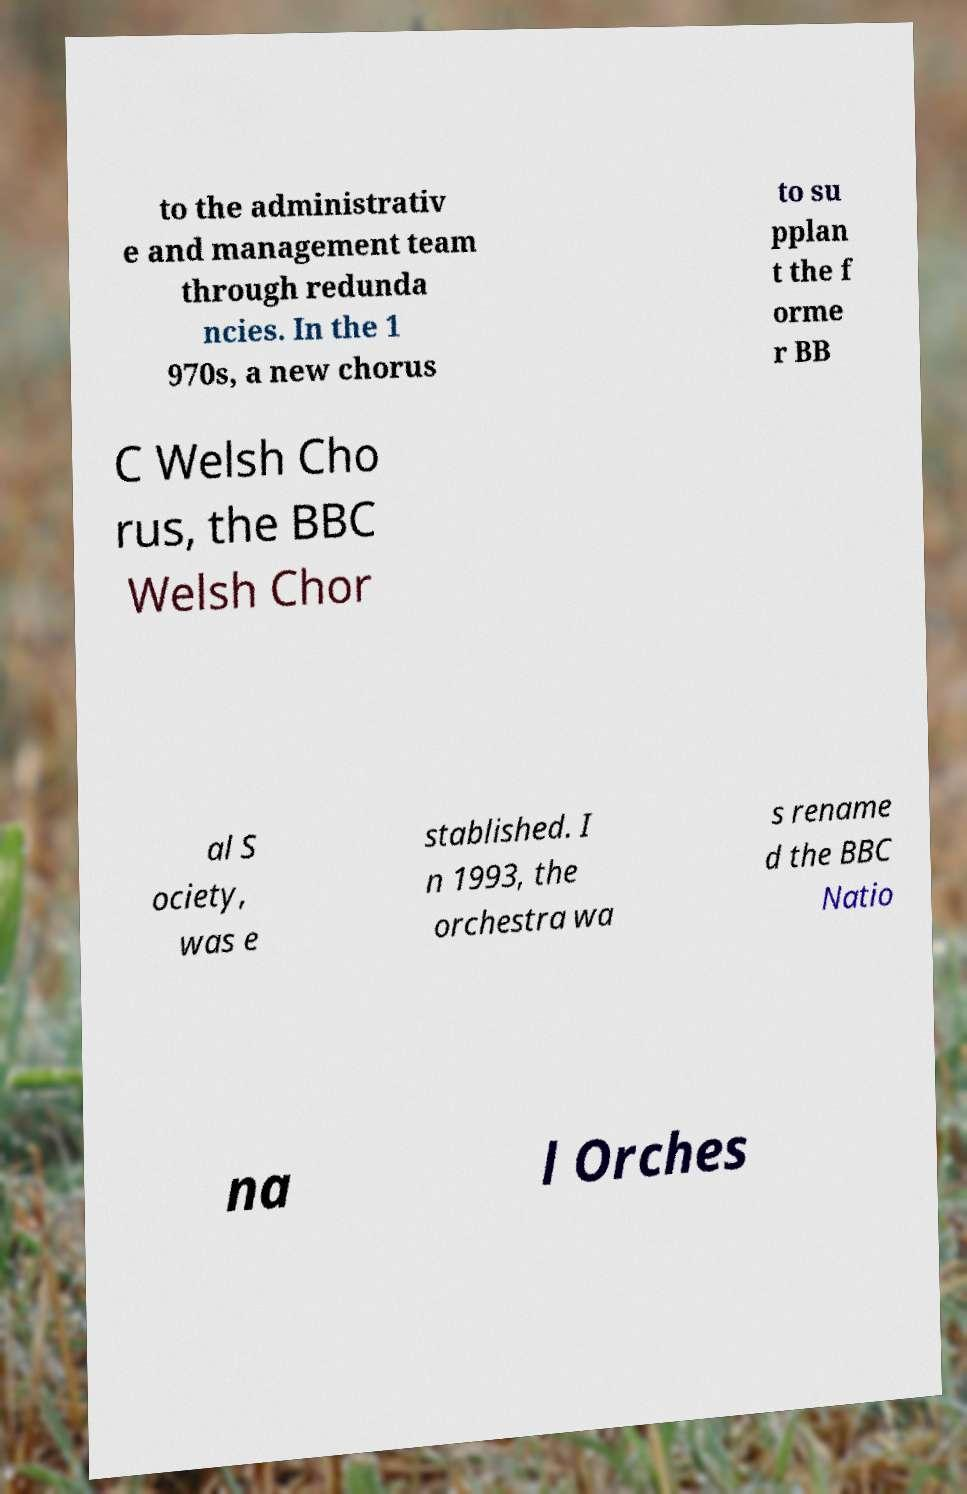Can you accurately transcribe the text from the provided image for me? to the administrativ e and management team through redunda ncies. In the 1 970s, a new chorus to su pplan t the f orme r BB C Welsh Cho rus, the BBC Welsh Chor al S ociety, was e stablished. I n 1993, the orchestra wa s rename d the BBC Natio na l Orches 